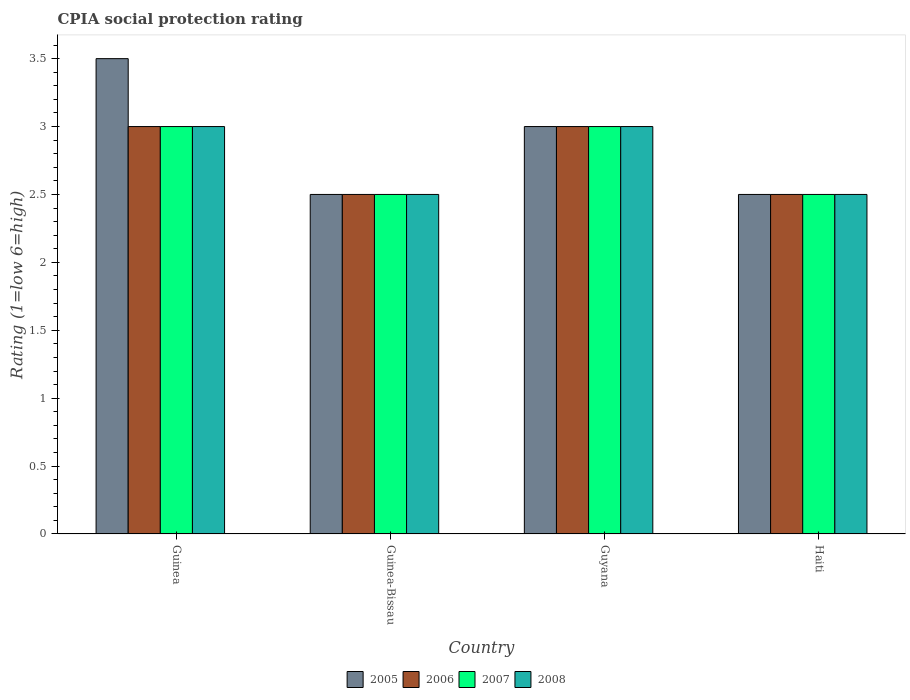How many different coloured bars are there?
Provide a succinct answer. 4. How many groups of bars are there?
Make the answer very short. 4. Are the number of bars on each tick of the X-axis equal?
Provide a succinct answer. Yes. How many bars are there on the 1st tick from the left?
Offer a terse response. 4. How many bars are there on the 1st tick from the right?
Your response must be concise. 4. What is the label of the 1st group of bars from the left?
Give a very brief answer. Guinea. In how many cases, is the number of bars for a given country not equal to the number of legend labels?
Ensure brevity in your answer.  0. Across all countries, what is the minimum CPIA rating in 2005?
Make the answer very short. 2.5. In which country was the CPIA rating in 2005 maximum?
Make the answer very short. Guinea. In which country was the CPIA rating in 2006 minimum?
Your answer should be compact. Guinea-Bissau. What is the difference between the CPIA rating in 2005 in Guinea and that in Guinea-Bissau?
Offer a terse response. 1. What is the average CPIA rating in 2006 per country?
Offer a terse response. 2.75. In how many countries, is the CPIA rating in 2007 greater than 1.5?
Your answer should be compact. 4. Is the CPIA rating in 2008 in Guinea less than that in Haiti?
Ensure brevity in your answer.  No. What is the difference between the highest and the second highest CPIA rating in 2008?
Give a very brief answer. -0.5. In how many countries, is the CPIA rating in 2007 greater than the average CPIA rating in 2007 taken over all countries?
Provide a succinct answer. 2. Is the sum of the CPIA rating in 2008 in Guinea-Bissau and Guyana greater than the maximum CPIA rating in 2006 across all countries?
Offer a very short reply. Yes. Is it the case that in every country, the sum of the CPIA rating in 2008 and CPIA rating in 2005 is greater than the CPIA rating in 2007?
Offer a very short reply. Yes. What is the difference between two consecutive major ticks on the Y-axis?
Provide a short and direct response. 0.5. Does the graph contain grids?
Provide a short and direct response. No. Where does the legend appear in the graph?
Ensure brevity in your answer.  Bottom center. How many legend labels are there?
Your response must be concise. 4. How are the legend labels stacked?
Provide a succinct answer. Horizontal. What is the title of the graph?
Offer a terse response. CPIA social protection rating. Does "1997" appear as one of the legend labels in the graph?
Provide a succinct answer. No. What is the label or title of the X-axis?
Your answer should be compact. Country. What is the label or title of the Y-axis?
Your answer should be very brief. Rating (1=low 6=high). What is the Rating (1=low 6=high) in 2005 in Guinea?
Provide a succinct answer. 3.5. What is the Rating (1=low 6=high) of 2007 in Guinea?
Give a very brief answer. 3. What is the Rating (1=low 6=high) in 2007 in Guinea-Bissau?
Make the answer very short. 2.5. What is the Rating (1=low 6=high) of 2006 in Guyana?
Your answer should be compact. 3. Across all countries, what is the maximum Rating (1=low 6=high) of 2005?
Offer a very short reply. 3.5. Across all countries, what is the maximum Rating (1=low 6=high) of 2008?
Ensure brevity in your answer.  3. Across all countries, what is the minimum Rating (1=low 6=high) of 2007?
Offer a terse response. 2.5. What is the difference between the Rating (1=low 6=high) of 2005 in Guinea and that in Guinea-Bissau?
Your response must be concise. 1. What is the difference between the Rating (1=low 6=high) of 2006 in Guinea and that in Guinea-Bissau?
Make the answer very short. 0.5. What is the difference between the Rating (1=low 6=high) of 2008 in Guinea and that in Guinea-Bissau?
Provide a succinct answer. 0.5. What is the difference between the Rating (1=low 6=high) of 2005 in Guinea and that in Guyana?
Keep it short and to the point. 0.5. What is the difference between the Rating (1=low 6=high) in 2006 in Guinea and that in Guyana?
Your answer should be compact. 0. What is the difference between the Rating (1=low 6=high) of 2008 in Guinea and that in Guyana?
Your response must be concise. 0. What is the difference between the Rating (1=low 6=high) of 2006 in Guinea and that in Haiti?
Keep it short and to the point. 0.5. What is the difference between the Rating (1=low 6=high) in 2007 in Guinea and that in Haiti?
Give a very brief answer. 0.5. What is the difference between the Rating (1=low 6=high) in 2005 in Guinea-Bissau and that in Guyana?
Keep it short and to the point. -0.5. What is the difference between the Rating (1=low 6=high) in 2006 in Guinea-Bissau and that in Guyana?
Make the answer very short. -0.5. What is the difference between the Rating (1=low 6=high) in 2006 in Guyana and that in Haiti?
Your answer should be compact. 0.5. What is the difference between the Rating (1=low 6=high) of 2007 in Guyana and that in Haiti?
Make the answer very short. 0.5. What is the difference between the Rating (1=low 6=high) in 2008 in Guyana and that in Haiti?
Your answer should be compact. 0.5. What is the difference between the Rating (1=low 6=high) in 2005 in Guinea and the Rating (1=low 6=high) in 2006 in Guinea-Bissau?
Provide a short and direct response. 1. What is the difference between the Rating (1=low 6=high) in 2005 in Guinea and the Rating (1=low 6=high) in 2007 in Guinea-Bissau?
Provide a short and direct response. 1. What is the difference between the Rating (1=low 6=high) of 2006 in Guinea and the Rating (1=low 6=high) of 2007 in Guinea-Bissau?
Offer a very short reply. 0.5. What is the difference between the Rating (1=low 6=high) of 2006 in Guinea and the Rating (1=low 6=high) of 2008 in Guinea-Bissau?
Ensure brevity in your answer.  0.5. What is the difference between the Rating (1=low 6=high) of 2005 in Guinea and the Rating (1=low 6=high) of 2006 in Guyana?
Keep it short and to the point. 0.5. What is the difference between the Rating (1=low 6=high) in 2006 in Guinea and the Rating (1=low 6=high) in 2007 in Guyana?
Your response must be concise. 0. What is the difference between the Rating (1=low 6=high) of 2007 in Guinea and the Rating (1=low 6=high) of 2008 in Guyana?
Provide a short and direct response. 0. What is the difference between the Rating (1=low 6=high) in 2005 in Guinea and the Rating (1=low 6=high) in 2006 in Haiti?
Offer a terse response. 1. What is the difference between the Rating (1=low 6=high) in 2005 in Guinea and the Rating (1=low 6=high) in 2007 in Haiti?
Keep it short and to the point. 1. What is the difference between the Rating (1=low 6=high) of 2006 in Guinea and the Rating (1=low 6=high) of 2008 in Haiti?
Provide a short and direct response. 0.5. What is the difference between the Rating (1=low 6=high) of 2007 in Guinea and the Rating (1=low 6=high) of 2008 in Haiti?
Ensure brevity in your answer.  0.5. What is the difference between the Rating (1=low 6=high) in 2005 in Guinea-Bissau and the Rating (1=low 6=high) in 2008 in Guyana?
Ensure brevity in your answer.  -0.5. What is the difference between the Rating (1=low 6=high) in 2006 in Guinea-Bissau and the Rating (1=low 6=high) in 2007 in Guyana?
Provide a short and direct response. -0.5. What is the difference between the Rating (1=low 6=high) of 2007 in Guinea-Bissau and the Rating (1=low 6=high) of 2008 in Guyana?
Offer a very short reply. -0.5. What is the difference between the Rating (1=low 6=high) of 2005 in Guinea-Bissau and the Rating (1=low 6=high) of 2008 in Haiti?
Give a very brief answer. 0. What is the difference between the Rating (1=low 6=high) of 2006 in Guinea-Bissau and the Rating (1=low 6=high) of 2007 in Haiti?
Provide a short and direct response. 0. What is the difference between the Rating (1=low 6=high) in 2006 in Guinea-Bissau and the Rating (1=low 6=high) in 2008 in Haiti?
Ensure brevity in your answer.  0. What is the difference between the Rating (1=low 6=high) of 2007 in Guyana and the Rating (1=low 6=high) of 2008 in Haiti?
Offer a very short reply. 0.5. What is the average Rating (1=low 6=high) of 2005 per country?
Give a very brief answer. 2.88. What is the average Rating (1=low 6=high) in 2006 per country?
Ensure brevity in your answer.  2.75. What is the average Rating (1=low 6=high) in 2007 per country?
Ensure brevity in your answer.  2.75. What is the average Rating (1=low 6=high) in 2008 per country?
Provide a short and direct response. 2.75. What is the difference between the Rating (1=low 6=high) of 2005 and Rating (1=low 6=high) of 2007 in Guinea?
Your answer should be compact. 0.5. What is the difference between the Rating (1=low 6=high) of 2006 and Rating (1=low 6=high) of 2007 in Guinea?
Offer a terse response. 0. What is the difference between the Rating (1=low 6=high) in 2006 and Rating (1=low 6=high) in 2008 in Guinea?
Ensure brevity in your answer.  0. What is the difference between the Rating (1=low 6=high) in 2005 and Rating (1=low 6=high) in 2006 in Guinea-Bissau?
Make the answer very short. 0. What is the difference between the Rating (1=low 6=high) in 2005 and Rating (1=low 6=high) in 2007 in Guinea-Bissau?
Give a very brief answer. 0. What is the difference between the Rating (1=low 6=high) of 2006 and Rating (1=low 6=high) of 2007 in Guinea-Bissau?
Provide a short and direct response. 0. What is the difference between the Rating (1=low 6=high) in 2006 and Rating (1=low 6=high) in 2008 in Guinea-Bissau?
Your answer should be compact. 0. What is the difference between the Rating (1=low 6=high) in 2007 and Rating (1=low 6=high) in 2008 in Guinea-Bissau?
Offer a terse response. 0. What is the difference between the Rating (1=low 6=high) of 2005 and Rating (1=low 6=high) of 2007 in Guyana?
Your answer should be compact. 0. What is the difference between the Rating (1=low 6=high) in 2005 and Rating (1=low 6=high) in 2008 in Guyana?
Keep it short and to the point. 0. What is the difference between the Rating (1=low 6=high) in 2006 and Rating (1=low 6=high) in 2007 in Guyana?
Offer a very short reply. 0. What is the difference between the Rating (1=low 6=high) of 2005 and Rating (1=low 6=high) of 2006 in Haiti?
Make the answer very short. 0. What is the difference between the Rating (1=low 6=high) of 2006 and Rating (1=low 6=high) of 2007 in Haiti?
Offer a terse response. 0. What is the difference between the Rating (1=low 6=high) in 2007 and Rating (1=low 6=high) in 2008 in Haiti?
Your response must be concise. 0. What is the ratio of the Rating (1=low 6=high) of 2006 in Guinea to that in Guinea-Bissau?
Keep it short and to the point. 1.2. What is the ratio of the Rating (1=low 6=high) in 2007 in Guinea to that in Guinea-Bissau?
Make the answer very short. 1.2. What is the ratio of the Rating (1=low 6=high) in 2006 in Guinea to that in Guyana?
Your response must be concise. 1. What is the ratio of the Rating (1=low 6=high) in 2007 in Guinea to that in Guyana?
Your answer should be compact. 1. What is the ratio of the Rating (1=low 6=high) of 2008 in Guinea to that in Guyana?
Offer a terse response. 1. What is the ratio of the Rating (1=low 6=high) of 2006 in Guinea to that in Haiti?
Ensure brevity in your answer.  1.2. What is the ratio of the Rating (1=low 6=high) in 2005 in Guinea-Bissau to that in Guyana?
Give a very brief answer. 0.83. What is the ratio of the Rating (1=low 6=high) of 2007 in Guinea-Bissau to that in Guyana?
Your response must be concise. 0.83. What is the ratio of the Rating (1=low 6=high) of 2008 in Guinea-Bissau to that in Guyana?
Make the answer very short. 0.83. What is the ratio of the Rating (1=low 6=high) in 2005 in Guinea-Bissau to that in Haiti?
Give a very brief answer. 1. What is the ratio of the Rating (1=low 6=high) in 2007 in Guinea-Bissau to that in Haiti?
Ensure brevity in your answer.  1. What is the ratio of the Rating (1=low 6=high) of 2008 in Guinea-Bissau to that in Haiti?
Your answer should be compact. 1. What is the ratio of the Rating (1=low 6=high) of 2005 in Guyana to that in Haiti?
Offer a very short reply. 1.2. What is the ratio of the Rating (1=low 6=high) in 2006 in Guyana to that in Haiti?
Your answer should be compact. 1.2. What is the ratio of the Rating (1=low 6=high) of 2007 in Guyana to that in Haiti?
Give a very brief answer. 1.2. What is the difference between the highest and the second highest Rating (1=low 6=high) of 2006?
Keep it short and to the point. 0. What is the difference between the highest and the second highest Rating (1=low 6=high) of 2007?
Provide a succinct answer. 0. What is the difference between the highest and the lowest Rating (1=low 6=high) of 2008?
Ensure brevity in your answer.  0.5. 